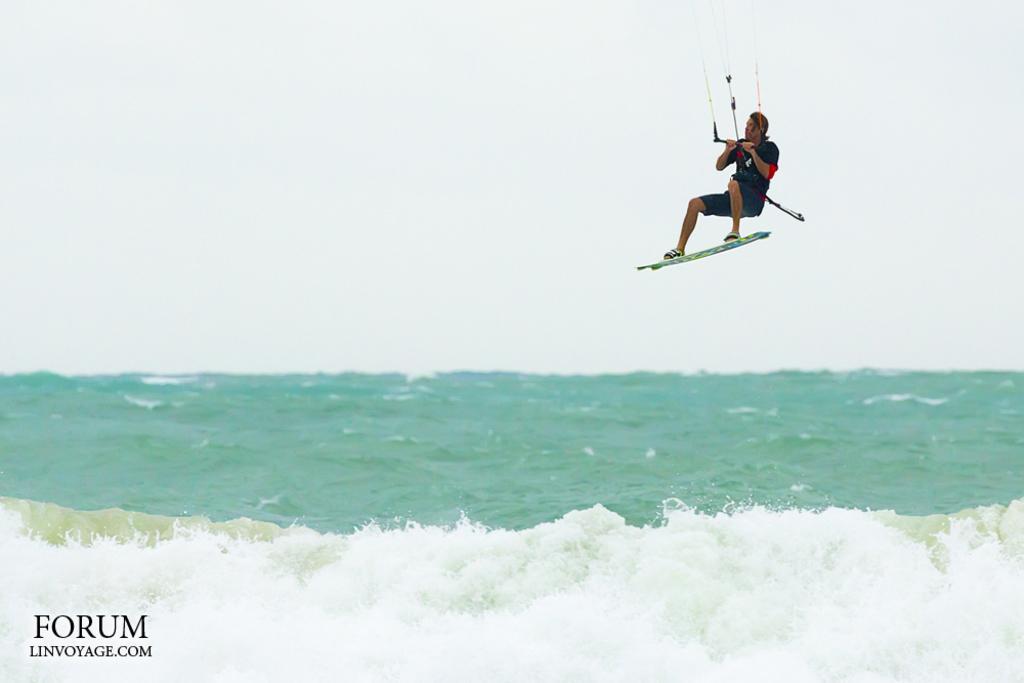Could you give a brief overview of what you see in this image? In the image we can see a person wearing clothes, this is a water board, water, sky and a watermark. These are the rope. 